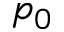<formula> <loc_0><loc_0><loc_500><loc_500>p _ { 0 }</formula> 